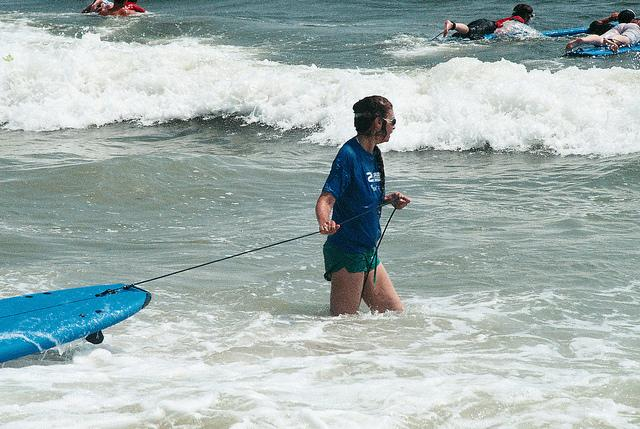What are surfboards made out of? Please explain your reasoning. rubber. The material helps the surf board float 